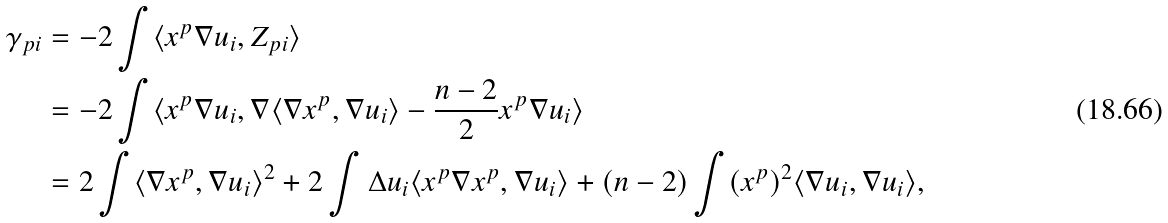Convert formula to latex. <formula><loc_0><loc_0><loc_500><loc_500>\gamma _ { p i } & = - 2 \int \langle x ^ { p } \nabla u _ { i } , Z _ { p i } \rangle \\ & = - 2 \int \langle x ^ { p } \nabla u _ { i } , \nabla \langle \nabla x ^ { p } , \nabla u _ { i } \rangle - \frac { n - 2 } 2 x ^ { p } \nabla u _ { i } \rangle \\ & = 2 \int \langle \nabla x ^ { p } , \nabla u _ { i } \rangle ^ { 2 } + 2 \int \Delta u _ { i } \langle x ^ { p } \nabla x ^ { p } , \nabla u _ { i } \rangle + ( n - 2 ) \int ( x ^ { p } ) ^ { 2 } \langle \nabla u _ { i } , \nabla u _ { i } \rangle , \\</formula> 